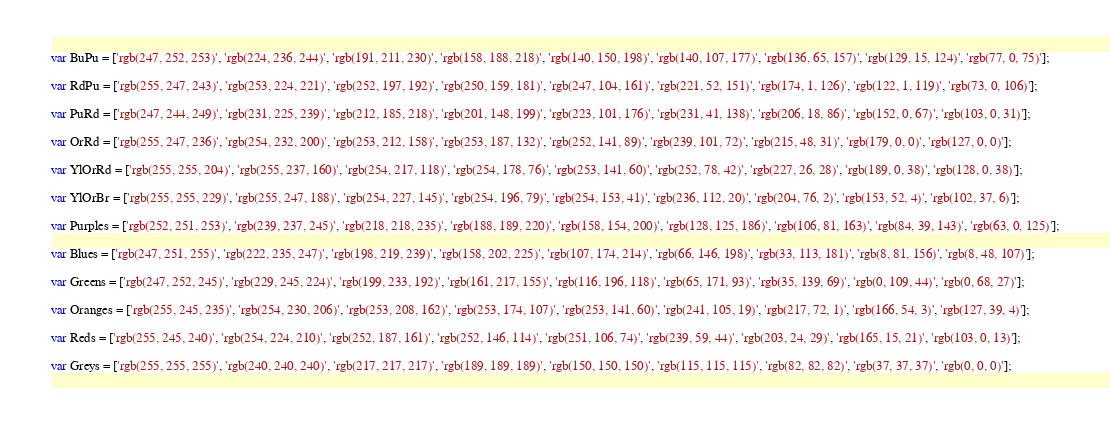Convert code to text. <code><loc_0><loc_0><loc_500><loc_500><_JavaScript_>
var BuPu = ['rgb(247, 252, 253)', 'rgb(224, 236, 244)', 'rgb(191, 211, 230)', 'rgb(158, 188, 218)', 'rgb(140, 150, 198)', 'rgb(140, 107, 177)', 'rgb(136, 65, 157)', 'rgb(129, 15, 124)', 'rgb(77, 0, 75)'];

var RdPu = ['rgb(255, 247, 243)', 'rgb(253, 224, 221)', 'rgb(252, 197, 192)', 'rgb(250, 159, 181)', 'rgb(247, 104, 161)', 'rgb(221, 52, 151)', 'rgb(174, 1, 126)', 'rgb(122, 1, 119)', 'rgb(73, 0, 106)'];

var PuRd = ['rgb(247, 244, 249)', 'rgb(231, 225, 239)', 'rgb(212, 185, 218)', 'rgb(201, 148, 199)', 'rgb(223, 101, 176)', 'rgb(231, 41, 138)', 'rgb(206, 18, 86)', 'rgb(152, 0, 67)', 'rgb(103, 0, 31)'];

var OrRd = ['rgb(255, 247, 236)', 'rgb(254, 232, 200)', 'rgb(253, 212, 158)', 'rgb(253, 187, 132)', 'rgb(252, 141, 89)', 'rgb(239, 101, 72)', 'rgb(215, 48, 31)', 'rgb(179, 0, 0)', 'rgb(127, 0, 0)'];

var YlOrRd = ['rgb(255, 255, 204)', 'rgb(255, 237, 160)', 'rgb(254, 217, 118)', 'rgb(254, 178, 76)', 'rgb(253, 141, 60)', 'rgb(252, 78, 42)', 'rgb(227, 26, 28)', 'rgb(189, 0, 38)', 'rgb(128, 0, 38)'];

var YlOrBr = ['rgb(255, 255, 229)', 'rgb(255, 247, 188)', 'rgb(254, 227, 145)', 'rgb(254, 196, 79)', 'rgb(254, 153, 41)', 'rgb(236, 112, 20)', 'rgb(204, 76, 2)', 'rgb(153, 52, 4)', 'rgb(102, 37, 6)'];

var Purples = ['rgb(252, 251, 253)', 'rgb(239, 237, 245)', 'rgb(218, 218, 235)', 'rgb(188, 189, 220)', 'rgb(158, 154, 200)', 'rgb(128, 125, 186)', 'rgb(106, 81, 163)', 'rgb(84, 39, 143)', 'rgb(63, 0, 125)'];

var Blues = ['rgb(247, 251, 255)', 'rgb(222, 235, 247)', 'rgb(198, 219, 239)', 'rgb(158, 202, 225)', 'rgb(107, 174, 214)', 'rgb(66, 146, 198)', 'rgb(33, 113, 181)', 'rgb(8, 81, 156)', 'rgb(8, 48, 107)'];

var Greens = ['rgb(247, 252, 245)', 'rgb(229, 245, 224)', 'rgb(199, 233, 192)', 'rgb(161, 217, 155)', 'rgb(116, 196, 118)', 'rgb(65, 171, 93)', 'rgb(35, 139, 69)', 'rgb(0, 109, 44)', 'rgb(0, 68, 27)'];

var Oranges = ['rgb(255, 245, 235)', 'rgb(254, 230, 206)', 'rgb(253, 208, 162)', 'rgb(253, 174, 107)', 'rgb(253, 141, 60)', 'rgb(241, 105, 19)', 'rgb(217, 72, 1)', 'rgb(166, 54, 3)', 'rgb(127, 39, 4)'];

var Reds = ['rgb(255, 245, 240)', 'rgb(254, 224, 210)', 'rgb(252, 187, 161)', 'rgb(252, 146, 114)', 'rgb(251, 106, 74)', 'rgb(239, 59, 44)', 'rgb(203, 24, 29)', 'rgb(165, 15, 21)', 'rgb(103, 0, 13)'];

var Greys = ['rgb(255, 255, 255)', 'rgb(240, 240, 240)', 'rgb(217, 217, 217)', 'rgb(189, 189, 189)', 'rgb(150, 150, 150)', 'rgb(115, 115, 115)', 'rgb(82, 82, 82)', 'rgb(37, 37, 37)', 'rgb(0, 0, 0)'];
</code> 